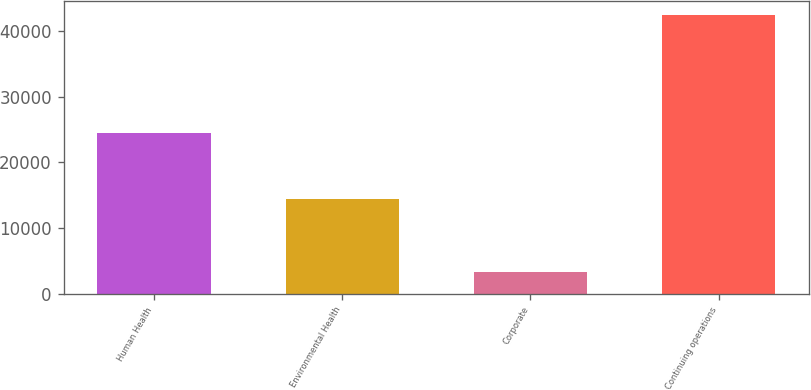<chart> <loc_0><loc_0><loc_500><loc_500><bar_chart><fcel>Human Health<fcel>Environmental Health<fcel>Corporate<fcel>Continuing operations<nl><fcel>24525<fcel>14488<fcel>3395<fcel>42408<nl></chart> 